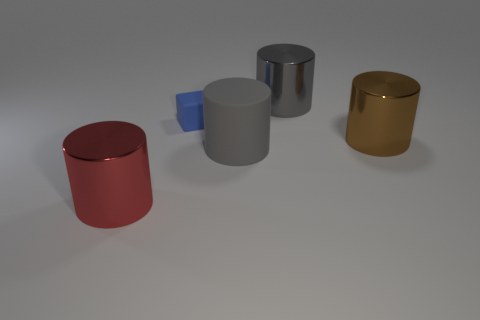How many other large red things are the same shape as the large red metallic thing?
Provide a short and direct response. 0. There is a object in front of the large gray matte cylinder; what is its color?
Ensure brevity in your answer.  Red. How many matte things are big green cubes or small things?
Your answer should be compact. 1. There is a big object that is the same color as the rubber cylinder; what is its shape?
Provide a short and direct response. Cylinder. How many red cylinders have the same size as the block?
Make the answer very short. 0. The big shiny cylinder that is both to the right of the large red thing and in front of the small blue rubber thing is what color?
Your response must be concise. Brown. What number of objects are large green matte things or metallic things?
Your response must be concise. 3. What number of big objects are purple shiny cubes or metal objects?
Provide a short and direct response. 3. Are there any other things that are the same color as the small thing?
Provide a succinct answer. No. There is a thing that is both on the left side of the rubber cylinder and on the right side of the large red cylinder; what is its size?
Provide a succinct answer. Small. 